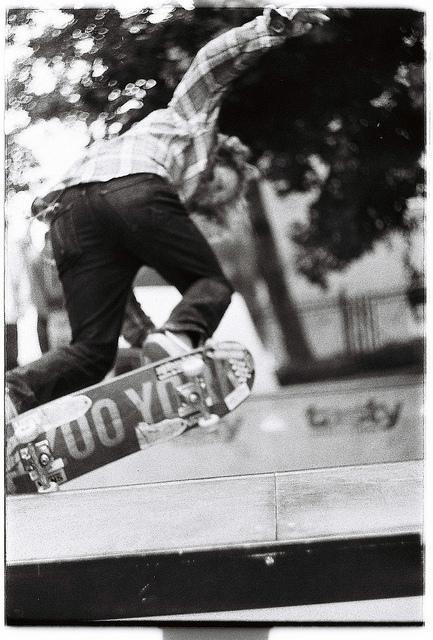How many skateboards can you see?
Give a very brief answer. 1. How many cars are there?
Give a very brief answer. 0. 